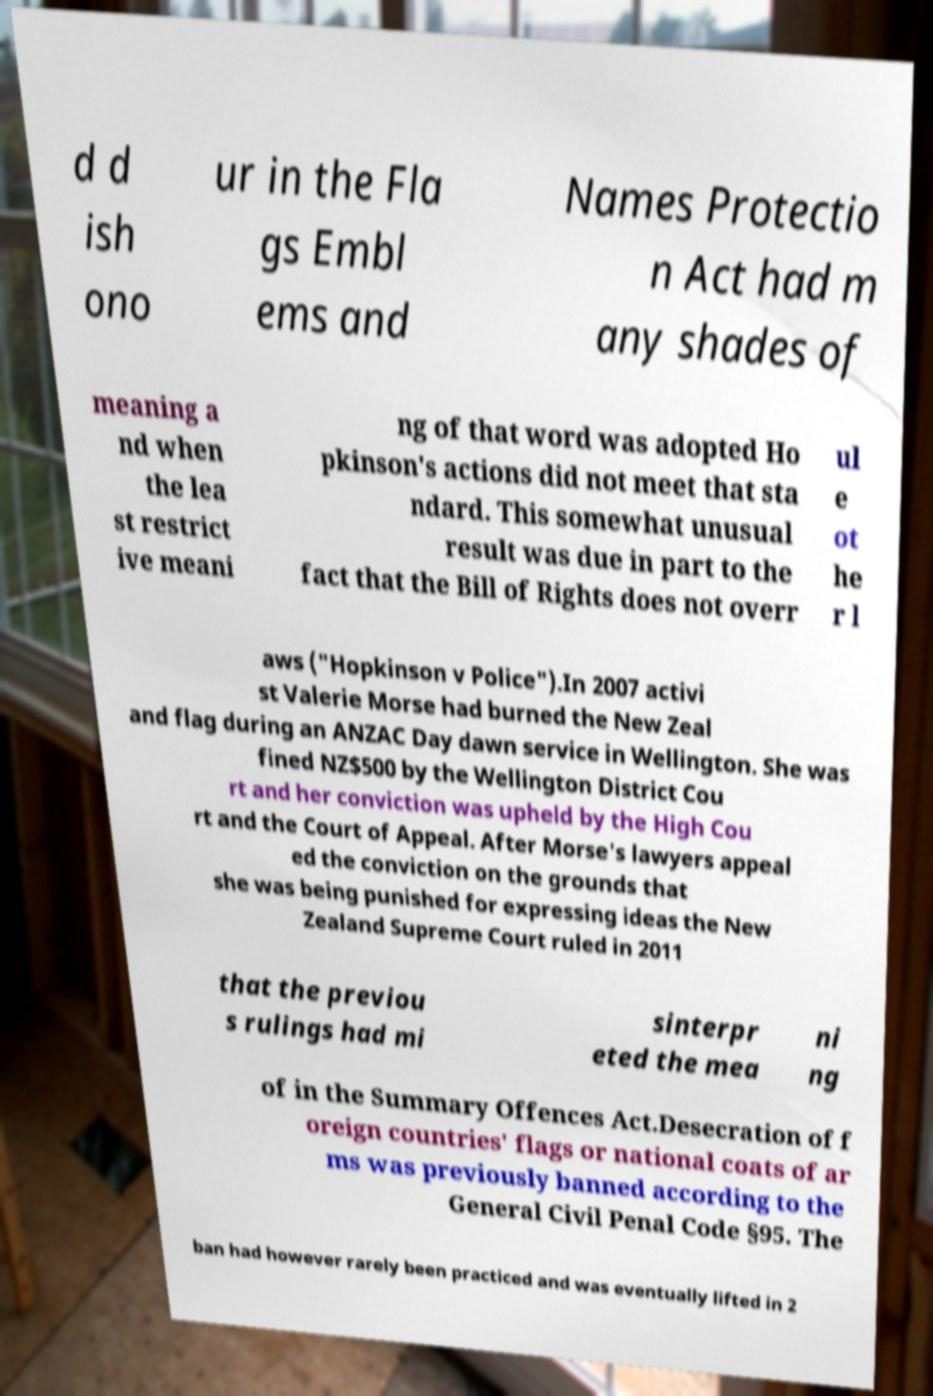Please identify and transcribe the text found in this image. d d ish ono ur in the Fla gs Embl ems and Names Protectio n Act had m any shades of meaning a nd when the lea st restrict ive meani ng of that word was adopted Ho pkinson's actions did not meet that sta ndard. This somewhat unusual result was due in part to the fact that the Bill of Rights does not overr ul e ot he r l aws ("Hopkinson v Police").In 2007 activi st Valerie Morse had burned the New Zeal and flag during an ANZAC Day dawn service in Wellington. She was fined NZ$500 by the Wellington District Cou rt and her conviction was upheld by the High Cou rt and the Court of Appeal. After Morse's lawyers appeal ed the conviction on the grounds that she was being punished for expressing ideas the New Zealand Supreme Court ruled in 2011 that the previou s rulings had mi sinterpr eted the mea ni ng of in the Summary Offences Act.Desecration of f oreign countries' flags or national coats of ar ms was previously banned according to the General Civil Penal Code §95. The ban had however rarely been practiced and was eventually lifted in 2 